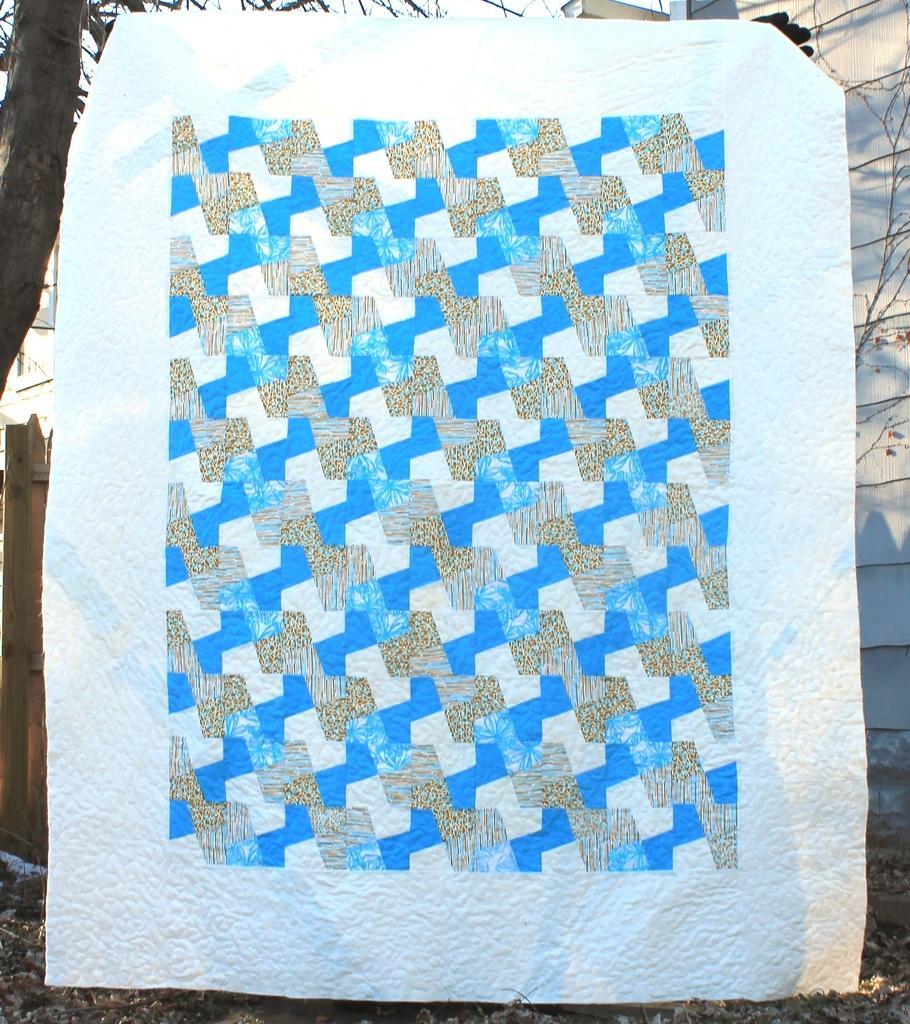Describe this image in one or two sentences. We can see banner. Background we can see wall and tree. 